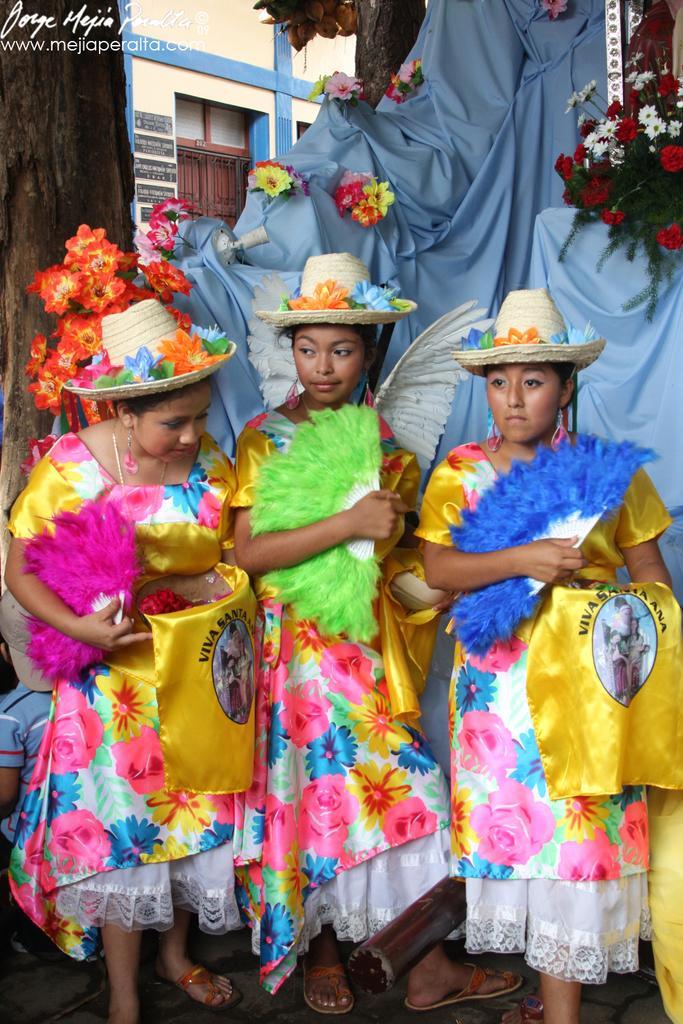In one or two sentences, can you explain what this image depicts? In this image, we can see three women wearing hat and yellow color dress. In the background, we can see a cloth, plant with some flowers, we can also see a building and a door. 